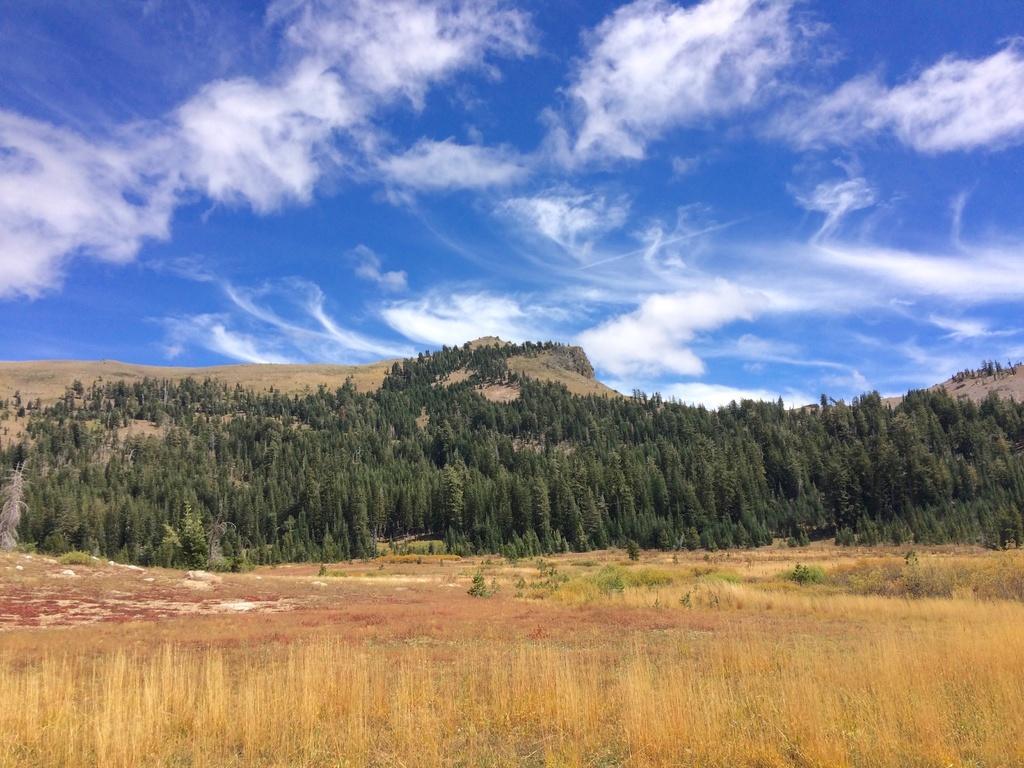Can you describe this image briefly? In this image I can see dried grass in brown color, trees in green color. Background the sky is in blue and white color. 